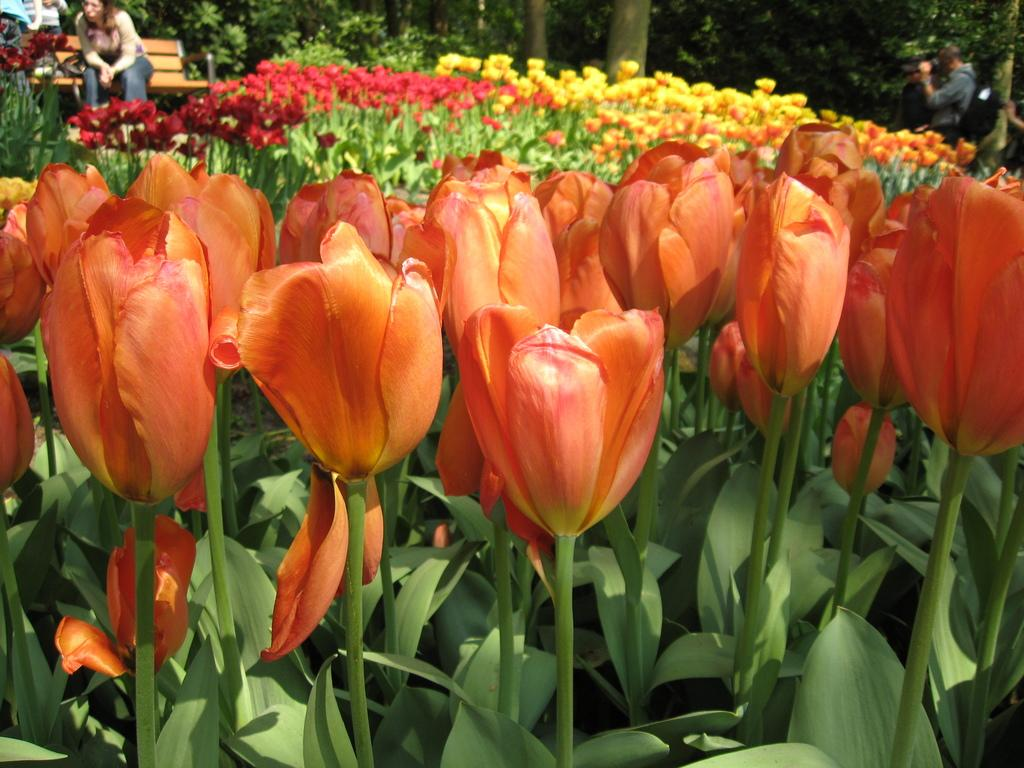What type of plants can be seen in the image? There are flowering plants in the image. How many people are present in the image? There are two persons in the image. What is the seating arrangement in the image? There is a bench in the image. What other natural elements are present in the image? There are trees in the image. Can you describe the setting of the image? The image appears to be taken in a garden. When was the image likely taken? The image was likely taken during the day. What type of stage can be seen in the image? There is no stage present in the image; it appears to be taken in a garden setting. How does the kite fly in the image? There is no kite present in the image, so it cannot be determined how it would fly. 